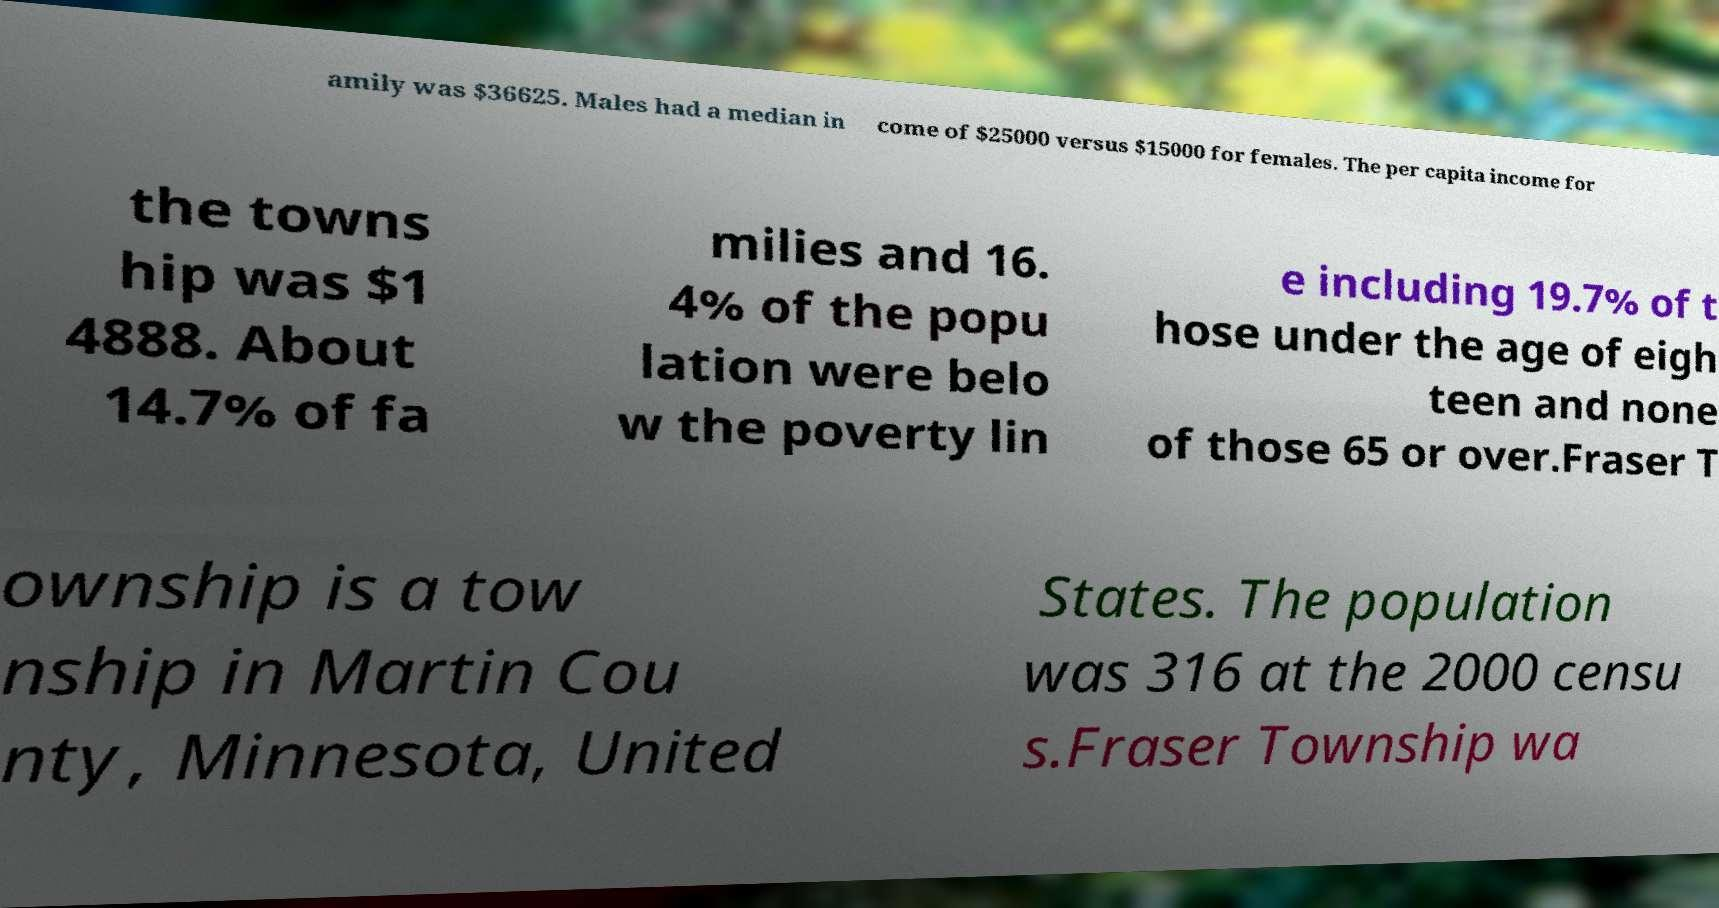What messages or text are displayed in this image? I need them in a readable, typed format. amily was $36625. Males had a median in come of $25000 versus $15000 for females. The per capita income for the towns hip was $1 4888. About 14.7% of fa milies and 16. 4% of the popu lation were belo w the poverty lin e including 19.7% of t hose under the age of eigh teen and none of those 65 or over.Fraser T ownship is a tow nship in Martin Cou nty, Minnesota, United States. The population was 316 at the 2000 censu s.Fraser Township wa 